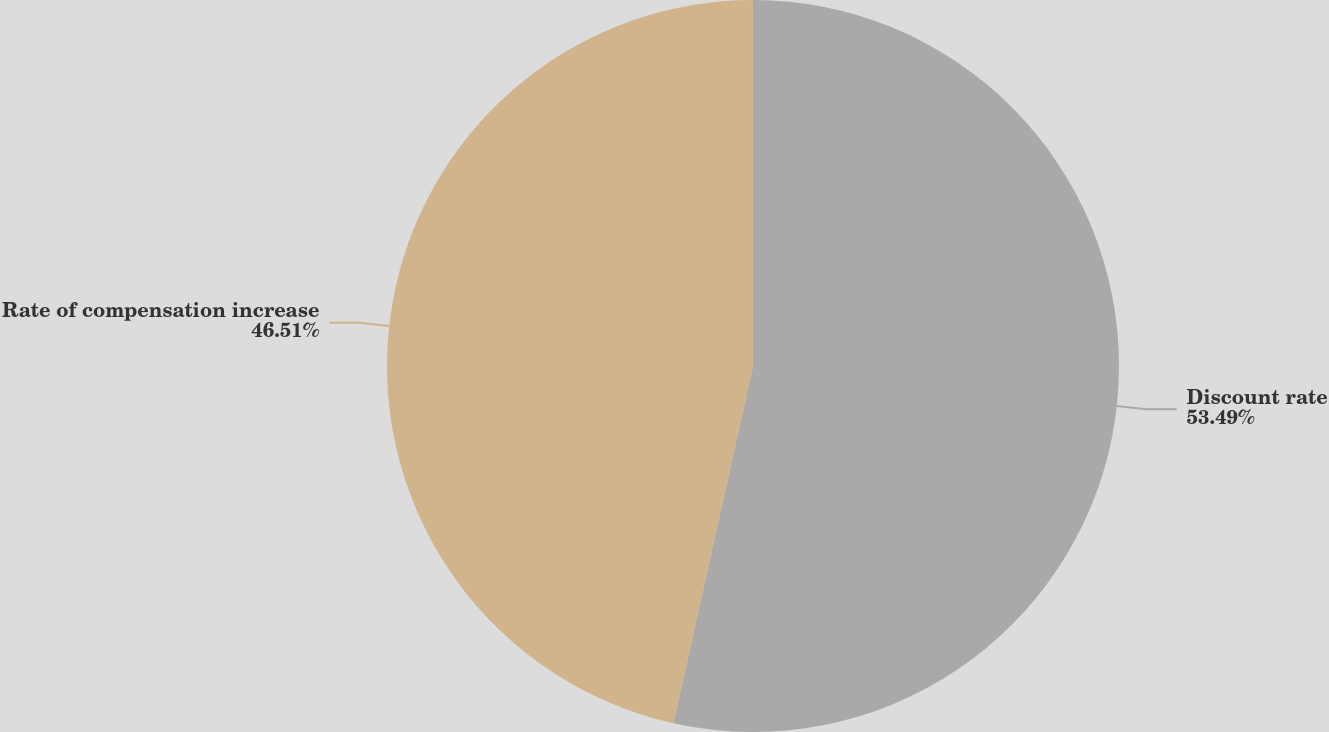Convert chart. <chart><loc_0><loc_0><loc_500><loc_500><pie_chart><fcel>Discount rate<fcel>Rate of compensation increase<nl><fcel>53.49%<fcel>46.51%<nl></chart> 